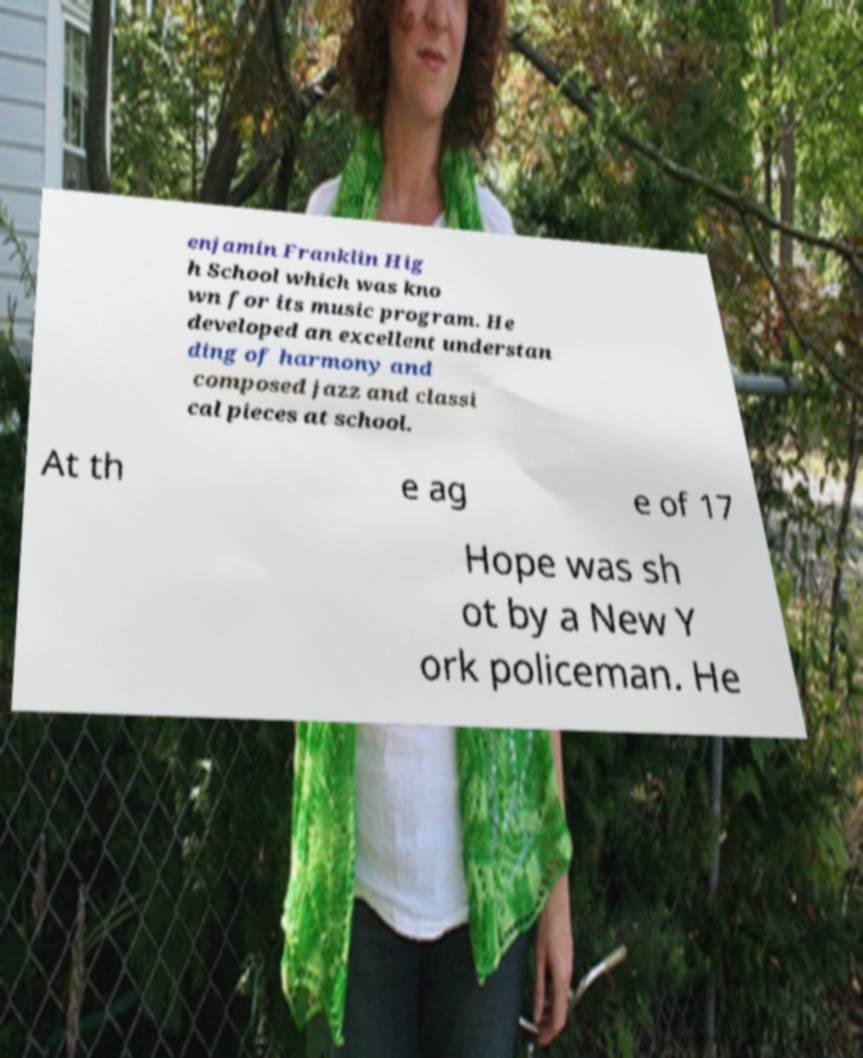Please identify and transcribe the text found in this image. enjamin Franklin Hig h School which was kno wn for its music program. He developed an excellent understan ding of harmony and composed jazz and classi cal pieces at school. At th e ag e of 17 Hope was sh ot by a New Y ork policeman. He 